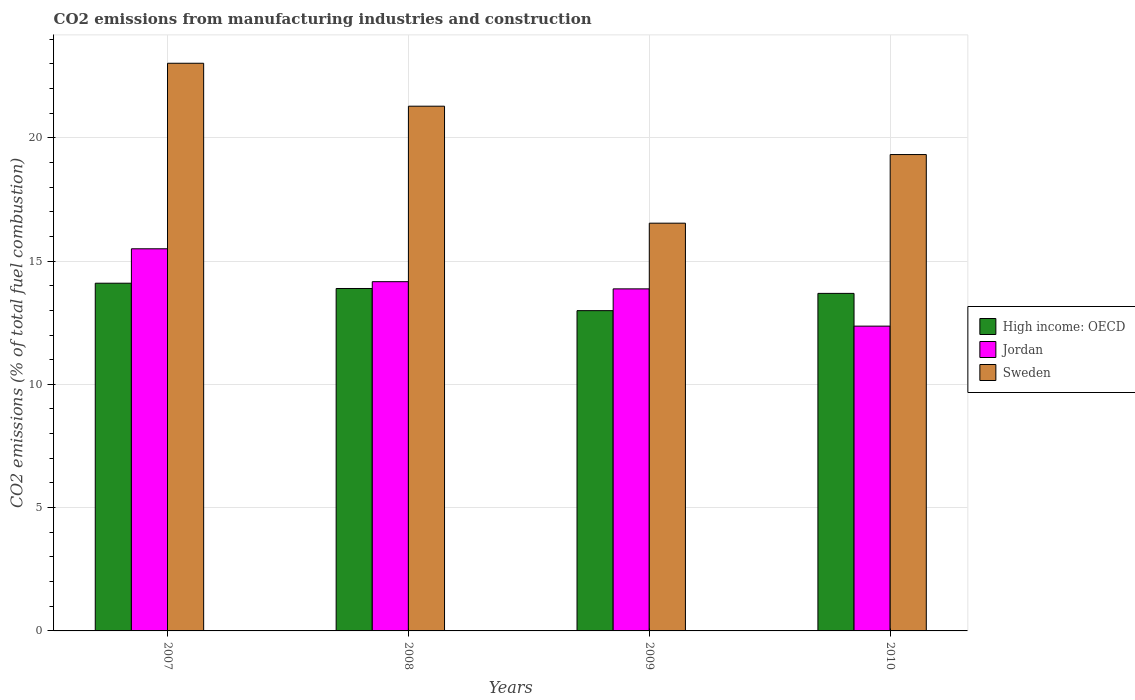How many groups of bars are there?
Your response must be concise. 4. Are the number of bars per tick equal to the number of legend labels?
Offer a very short reply. Yes. How many bars are there on the 4th tick from the right?
Your response must be concise. 3. In how many cases, is the number of bars for a given year not equal to the number of legend labels?
Your answer should be compact. 0. What is the amount of CO2 emitted in Jordan in 2009?
Offer a terse response. 13.87. Across all years, what is the maximum amount of CO2 emitted in High income: OECD?
Your answer should be compact. 14.1. Across all years, what is the minimum amount of CO2 emitted in High income: OECD?
Provide a succinct answer. 12.99. What is the total amount of CO2 emitted in High income: OECD in the graph?
Provide a succinct answer. 54.66. What is the difference between the amount of CO2 emitted in High income: OECD in 2008 and that in 2010?
Offer a terse response. 0.2. What is the difference between the amount of CO2 emitted in Sweden in 2008 and the amount of CO2 emitted in High income: OECD in 2010?
Provide a short and direct response. 7.59. What is the average amount of CO2 emitted in Jordan per year?
Make the answer very short. 13.97. In the year 2009, what is the difference between the amount of CO2 emitted in Sweden and amount of CO2 emitted in Jordan?
Make the answer very short. 2.66. What is the ratio of the amount of CO2 emitted in Sweden in 2008 to that in 2010?
Provide a short and direct response. 1.1. Is the amount of CO2 emitted in High income: OECD in 2008 less than that in 2009?
Your response must be concise. No. What is the difference between the highest and the second highest amount of CO2 emitted in Jordan?
Your answer should be very brief. 1.33. What is the difference between the highest and the lowest amount of CO2 emitted in High income: OECD?
Keep it short and to the point. 1.11. Is the sum of the amount of CO2 emitted in Jordan in 2007 and 2008 greater than the maximum amount of CO2 emitted in High income: OECD across all years?
Your answer should be very brief. Yes. What does the 2nd bar from the left in 2007 represents?
Offer a terse response. Jordan. What does the 3rd bar from the right in 2007 represents?
Provide a succinct answer. High income: OECD. Is it the case that in every year, the sum of the amount of CO2 emitted in High income: OECD and amount of CO2 emitted in Jordan is greater than the amount of CO2 emitted in Sweden?
Provide a succinct answer. Yes. Are all the bars in the graph horizontal?
Offer a very short reply. No. How many years are there in the graph?
Offer a very short reply. 4. What is the difference between two consecutive major ticks on the Y-axis?
Keep it short and to the point. 5. Are the values on the major ticks of Y-axis written in scientific E-notation?
Keep it short and to the point. No. Does the graph contain any zero values?
Your answer should be compact. No. Does the graph contain grids?
Your answer should be very brief. Yes. Where does the legend appear in the graph?
Ensure brevity in your answer.  Center right. How many legend labels are there?
Your answer should be very brief. 3. What is the title of the graph?
Make the answer very short. CO2 emissions from manufacturing industries and construction. What is the label or title of the X-axis?
Your answer should be compact. Years. What is the label or title of the Y-axis?
Offer a terse response. CO2 emissions (% of total fuel combustion). What is the CO2 emissions (% of total fuel combustion) of High income: OECD in 2007?
Keep it short and to the point. 14.1. What is the CO2 emissions (% of total fuel combustion) of Jordan in 2007?
Provide a succinct answer. 15.5. What is the CO2 emissions (% of total fuel combustion) of Sweden in 2007?
Offer a very short reply. 23.02. What is the CO2 emissions (% of total fuel combustion) in High income: OECD in 2008?
Provide a succinct answer. 13.89. What is the CO2 emissions (% of total fuel combustion) in Jordan in 2008?
Provide a succinct answer. 14.16. What is the CO2 emissions (% of total fuel combustion) in Sweden in 2008?
Keep it short and to the point. 21.28. What is the CO2 emissions (% of total fuel combustion) of High income: OECD in 2009?
Your response must be concise. 12.99. What is the CO2 emissions (% of total fuel combustion) of Jordan in 2009?
Offer a very short reply. 13.87. What is the CO2 emissions (% of total fuel combustion) of Sweden in 2009?
Give a very brief answer. 16.54. What is the CO2 emissions (% of total fuel combustion) of High income: OECD in 2010?
Your answer should be very brief. 13.69. What is the CO2 emissions (% of total fuel combustion) of Jordan in 2010?
Make the answer very short. 12.36. What is the CO2 emissions (% of total fuel combustion) in Sweden in 2010?
Make the answer very short. 19.32. Across all years, what is the maximum CO2 emissions (% of total fuel combustion) in High income: OECD?
Keep it short and to the point. 14.1. Across all years, what is the maximum CO2 emissions (% of total fuel combustion) of Jordan?
Offer a very short reply. 15.5. Across all years, what is the maximum CO2 emissions (% of total fuel combustion) in Sweden?
Provide a short and direct response. 23.02. Across all years, what is the minimum CO2 emissions (% of total fuel combustion) of High income: OECD?
Provide a short and direct response. 12.99. Across all years, what is the minimum CO2 emissions (% of total fuel combustion) of Jordan?
Make the answer very short. 12.36. Across all years, what is the minimum CO2 emissions (% of total fuel combustion) in Sweden?
Give a very brief answer. 16.54. What is the total CO2 emissions (% of total fuel combustion) of High income: OECD in the graph?
Offer a very short reply. 54.66. What is the total CO2 emissions (% of total fuel combustion) of Jordan in the graph?
Your response must be concise. 55.89. What is the total CO2 emissions (% of total fuel combustion) in Sweden in the graph?
Give a very brief answer. 80.15. What is the difference between the CO2 emissions (% of total fuel combustion) in High income: OECD in 2007 and that in 2008?
Provide a short and direct response. 0.21. What is the difference between the CO2 emissions (% of total fuel combustion) of Jordan in 2007 and that in 2008?
Offer a terse response. 1.33. What is the difference between the CO2 emissions (% of total fuel combustion) in Sweden in 2007 and that in 2008?
Ensure brevity in your answer.  1.74. What is the difference between the CO2 emissions (% of total fuel combustion) in High income: OECD in 2007 and that in 2009?
Your response must be concise. 1.11. What is the difference between the CO2 emissions (% of total fuel combustion) of Jordan in 2007 and that in 2009?
Make the answer very short. 1.62. What is the difference between the CO2 emissions (% of total fuel combustion) of Sweden in 2007 and that in 2009?
Make the answer very short. 6.49. What is the difference between the CO2 emissions (% of total fuel combustion) of High income: OECD in 2007 and that in 2010?
Your answer should be very brief. 0.41. What is the difference between the CO2 emissions (% of total fuel combustion) of Jordan in 2007 and that in 2010?
Keep it short and to the point. 3.14. What is the difference between the CO2 emissions (% of total fuel combustion) of Sweden in 2007 and that in 2010?
Provide a short and direct response. 3.7. What is the difference between the CO2 emissions (% of total fuel combustion) of High income: OECD in 2008 and that in 2009?
Give a very brief answer. 0.9. What is the difference between the CO2 emissions (% of total fuel combustion) of Jordan in 2008 and that in 2009?
Provide a short and direct response. 0.29. What is the difference between the CO2 emissions (% of total fuel combustion) in Sweden in 2008 and that in 2009?
Your answer should be very brief. 4.74. What is the difference between the CO2 emissions (% of total fuel combustion) in High income: OECD in 2008 and that in 2010?
Provide a short and direct response. 0.2. What is the difference between the CO2 emissions (% of total fuel combustion) in Jordan in 2008 and that in 2010?
Give a very brief answer. 1.8. What is the difference between the CO2 emissions (% of total fuel combustion) of Sweden in 2008 and that in 2010?
Provide a succinct answer. 1.96. What is the difference between the CO2 emissions (% of total fuel combustion) in High income: OECD in 2009 and that in 2010?
Ensure brevity in your answer.  -0.7. What is the difference between the CO2 emissions (% of total fuel combustion) in Jordan in 2009 and that in 2010?
Offer a very short reply. 1.51. What is the difference between the CO2 emissions (% of total fuel combustion) in Sweden in 2009 and that in 2010?
Your answer should be very brief. -2.78. What is the difference between the CO2 emissions (% of total fuel combustion) in High income: OECD in 2007 and the CO2 emissions (% of total fuel combustion) in Jordan in 2008?
Make the answer very short. -0.06. What is the difference between the CO2 emissions (% of total fuel combustion) in High income: OECD in 2007 and the CO2 emissions (% of total fuel combustion) in Sweden in 2008?
Offer a terse response. -7.18. What is the difference between the CO2 emissions (% of total fuel combustion) in Jordan in 2007 and the CO2 emissions (% of total fuel combustion) in Sweden in 2008?
Your answer should be very brief. -5.78. What is the difference between the CO2 emissions (% of total fuel combustion) of High income: OECD in 2007 and the CO2 emissions (% of total fuel combustion) of Jordan in 2009?
Offer a terse response. 0.23. What is the difference between the CO2 emissions (% of total fuel combustion) of High income: OECD in 2007 and the CO2 emissions (% of total fuel combustion) of Sweden in 2009?
Make the answer very short. -2.43. What is the difference between the CO2 emissions (% of total fuel combustion) in Jordan in 2007 and the CO2 emissions (% of total fuel combustion) in Sweden in 2009?
Make the answer very short. -1.04. What is the difference between the CO2 emissions (% of total fuel combustion) of High income: OECD in 2007 and the CO2 emissions (% of total fuel combustion) of Jordan in 2010?
Keep it short and to the point. 1.74. What is the difference between the CO2 emissions (% of total fuel combustion) in High income: OECD in 2007 and the CO2 emissions (% of total fuel combustion) in Sweden in 2010?
Your response must be concise. -5.22. What is the difference between the CO2 emissions (% of total fuel combustion) in Jordan in 2007 and the CO2 emissions (% of total fuel combustion) in Sweden in 2010?
Your response must be concise. -3.82. What is the difference between the CO2 emissions (% of total fuel combustion) of High income: OECD in 2008 and the CO2 emissions (% of total fuel combustion) of Jordan in 2009?
Provide a short and direct response. 0.01. What is the difference between the CO2 emissions (% of total fuel combustion) in High income: OECD in 2008 and the CO2 emissions (% of total fuel combustion) in Sweden in 2009?
Keep it short and to the point. -2.65. What is the difference between the CO2 emissions (% of total fuel combustion) in Jordan in 2008 and the CO2 emissions (% of total fuel combustion) in Sweden in 2009?
Give a very brief answer. -2.37. What is the difference between the CO2 emissions (% of total fuel combustion) in High income: OECD in 2008 and the CO2 emissions (% of total fuel combustion) in Jordan in 2010?
Provide a short and direct response. 1.53. What is the difference between the CO2 emissions (% of total fuel combustion) in High income: OECD in 2008 and the CO2 emissions (% of total fuel combustion) in Sweden in 2010?
Your answer should be very brief. -5.43. What is the difference between the CO2 emissions (% of total fuel combustion) in Jordan in 2008 and the CO2 emissions (% of total fuel combustion) in Sweden in 2010?
Your response must be concise. -5.16. What is the difference between the CO2 emissions (% of total fuel combustion) of High income: OECD in 2009 and the CO2 emissions (% of total fuel combustion) of Jordan in 2010?
Give a very brief answer. 0.63. What is the difference between the CO2 emissions (% of total fuel combustion) in High income: OECD in 2009 and the CO2 emissions (% of total fuel combustion) in Sweden in 2010?
Offer a very short reply. -6.33. What is the difference between the CO2 emissions (% of total fuel combustion) in Jordan in 2009 and the CO2 emissions (% of total fuel combustion) in Sweden in 2010?
Keep it short and to the point. -5.45. What is the average CO2 emissions (% of total fuel combustion) of High income: OECD per year?
Make the answer very short. 13.67. What is the average CO2 emissions (% of total fuel combustion) in Jordan per year?
Keep it short and to the point. 13.97. What is the average CO2 emissions (% of total fuel combustion) of Sweden per year?
Keep it short and to the point. 20.04. In the year 2007, what is the difference between the CO2 emissions (% of total fuel combustion) of High income: OECD and CO2 emissions (% of total fuel combustion) of Jordan?
Give a very brief answer. -1.4. In the year 2007, what is the difference between the CO2 emissions (% of total fuel combustion) in High income: OECD and CO2 emissions (% of total fuel combustion) in Sweden?
Your answer should be very brief. -8.92. In the year 2007, what is the difference between the CO2 emissions (% of total fuel combustion) in Jordan and CO2 emissions (% of total fuel combustion) in Sweden?
Your response must be concise. -7.52. In the year 2008, what is the difference between the CO2 emissions (% of total fuel combustion) of High income: OECD and CO2 emissions (% of total fuel combustion) of Jordan?
Offer a very short reply. -0.28. In the year 2008, what is the difference between the CO2 emissions (% of total fuel combustion) of High income: OECD and CO2 emissions (% of total fuel combustion) of Sweden?
Your answer should be very brief. -7.39. In the year 2008, what is the difference between the CO2 emissions (% of total fuel combustion) in Jordan and CO2 emissions (% of total fuel combustion) in Sweden?
Give a very brief answer. -7.12. In the year 2009, what is the difference between the CO2 emissions (% of total fuel combustion) in High income: OECD and CO2 emissions (% of total fuel combustion) in Jordan?
Provide a succinct answer. -0.88. In the year 2009, what is the difference between the CO2 emissions (% of total fuel combustion) in High income: OECD and CO2 emissions (% of total fuel combustion) in Sweden?
Offer a very short reply. -3.55. In the year 2009, what is the difference between the CO2 emissions (% of total fuel combustion) in Jordan and CO2 emissions (% of total fuel combustion) in Sweden?
Your answer should be compact. -2.66. In the year 2010, what is the difference between the CO2 emissions (% of total fuel combustion) of High income: OECD and CO2 emissions (% of total fuel combustion) of Jordan?
Offer a terse response. 1.33. In the year 2010, what is the difference between the CO2 emissions (% of total fuel combustion) in High income: OECD and CO2 emissions (% of total fuel combustion) in Sweden?
Offer a very short reply. -5.63. In the year 2010, what is the difference between the CO2 emissions (% of total fuel combustion) of Jordan and CO2 emissions (% of total fuel combustion) of Sweden?
Ensure brevity in your answer.  -6.96. What is the ratio of the CO2 emissions (% of total fuel combustion) of High income: OECD in 2007 to that in 2008?
Give a very brief answer. 1.02. What is the ratio of the CO2 emissions (% of total fuel combustion) of Jordan in 2007 to that in 2008?
Your response must be concise. 1.09. What is the ratio of the CO2 emissions (% of total fuel combustion) of Sweden in 2007 to that in 2008?
Your answer should be very brief. 1.08. What is the ratio of the CO2 emissions (% of total fuel combustion) in High income: OECD in 2007 to that in 2009?
Keep it short and to the point. 1.09. What is the ratio of the CO2 emissions (% of total fuel combustion) of Jordan in 2007 to that in 2009?
Offer a very short reply. 1.12. What is the ratio of the CO2 emissions (% of total fuel combustion) in Sweden in 2007 to that in 2009?
Make the answer very short. 1.39. What is the ratio of the CO2 emissions (% of total fuel combustion) in High income: OECD in 2007 to that in 2010?
Give a very brief answer. 1.03. What is the ratio of the CO2 emissions (% of total fuel combustion) in Jordan in 2007 to that in 2010?
Your answer should be very brief. 1.25. What is the ratio of the CO2 emissions (% of total fuel combustion) of Sweden in 2007 to that in 2010?
Ensure brevity in your answer.  1.19. What is the ratio of the CO2 emissions (% of total fuel combustion) in High income: OECD in 2008 to that in 2009?
Offer a very short reply. 1.07. What is the ratio of the CO2 emissions (% of total fuel combustion) of Sweden in 2008 to that in 2009?
Keep it short and to the point. 1.29. What is the ratio of the CO2 emissions (% of total fuel combustion) of High income: OECD in 2008 to that in 2010?
Make the answer very short. 1.01. What is the ratio of the CO2 emissions (% of total fuel combustion) of Jordan in 2008 to that in 2010?
Your answer should be compact. 1.15. What is the ratio of the CO2 emissions (% of total fuel combustion) of Sweden in 2008 to that in 2010?
Offer a terse response. 1.1. What is the ratio of the CO2 emissions (% of total fuel combustion) of High income: OECD in 2009 to that in 2010?
Keep it short and to the point. 0.95. What is the ratio of the CO2 emissions (% of total fuel combustion) of Jordan in 2009 to that in 2010?
Your response must be concise. 1.12. What is the ratio of the CO2 emissions (% of total fuel combustion) in Sweden in 2009 to that in 2010?
Ensure brevity in your answer.  0.86. What is the difference between the highest and the second highest CO2 emissions (% of total fuel combustion) in High income: OECD?
Keep it short and to the point. 0.21. What is the difference between the highest and the second highest CO2 emissions (% of total fuel combustion) in Jordan?
Ensure brevity in your answer.  1.33. What is the difference between the highest and the second highest CO2 emissions (% of total fuel combustion) of Sweden?
Ensure brevity in your answer.  1.74. What is the difference between the highest and the lowest CO2 emissions (% of total fuel combustion) in High income: OECD?
Your response must be concise. 1.11. What is the difference between the highest and the lowest CO2 emissions (% of total fuel combustion) of Jordan?
Your response must be concise. 3.14. What is the difference between the highest and the lowest CO2 emissions (% of total fuel combustion) of Sweden?
Offer a terse response. 6.49. 